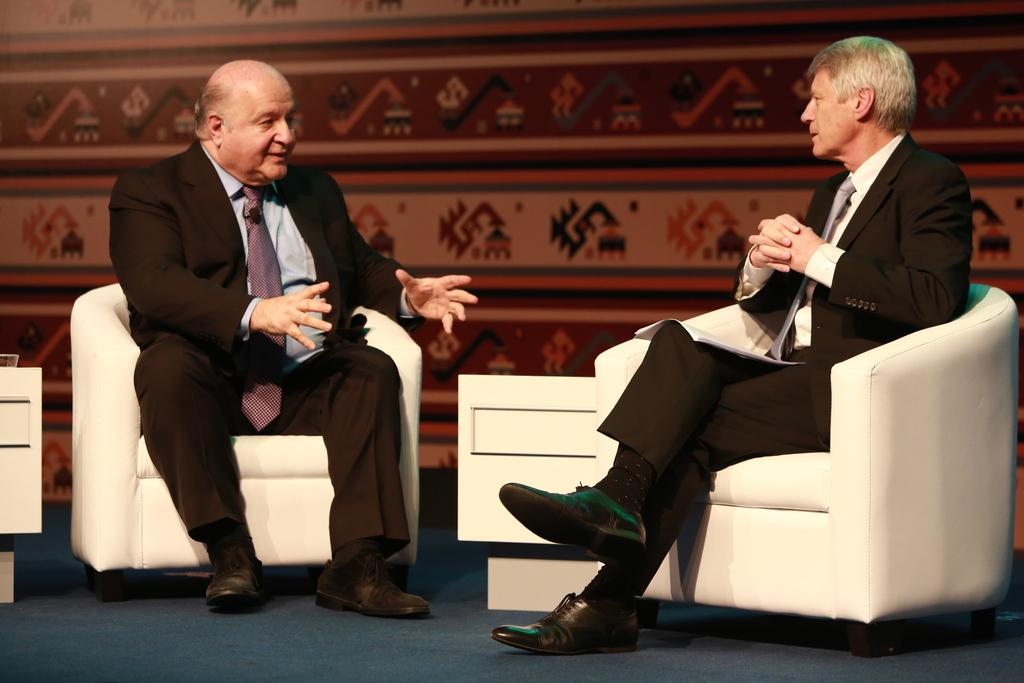How many people are in the image? There are two persons in the image. What are the persons doing in the image? The persons are sitting on a sofa and talking to each other. What are the persons wearing in the image? Both persons are wearing black coats, ties, and shoes. What type of voyage are the persons embarking on in the image? There is no indication of a voyage in the image. What line can be seen in the image? There is no line visible in the image. 